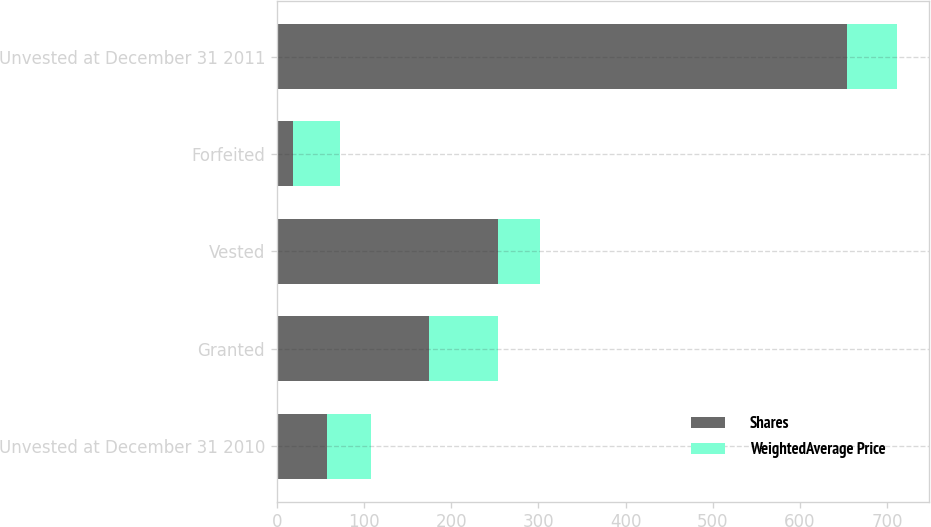Convert chart. <chart><loc_0><loc_0><loc_500><loc_500><stacked_bar_chart><ecel><fcel>Unvested at December 31 2010<fcel>Granted<fcel>Vested<fcel>Forfeited<fcel>Unvested at December 31 2011<nl><fcel>Shares<fcel>57.94<fcel>175<fcel>254<fcel>19<fcel>654<nl><fcel>WeightedAverage Price<fcel>49.64<fcel>78.99<fcel>48.16<fcel>54.06<fcel>57.94<nl></chart> 